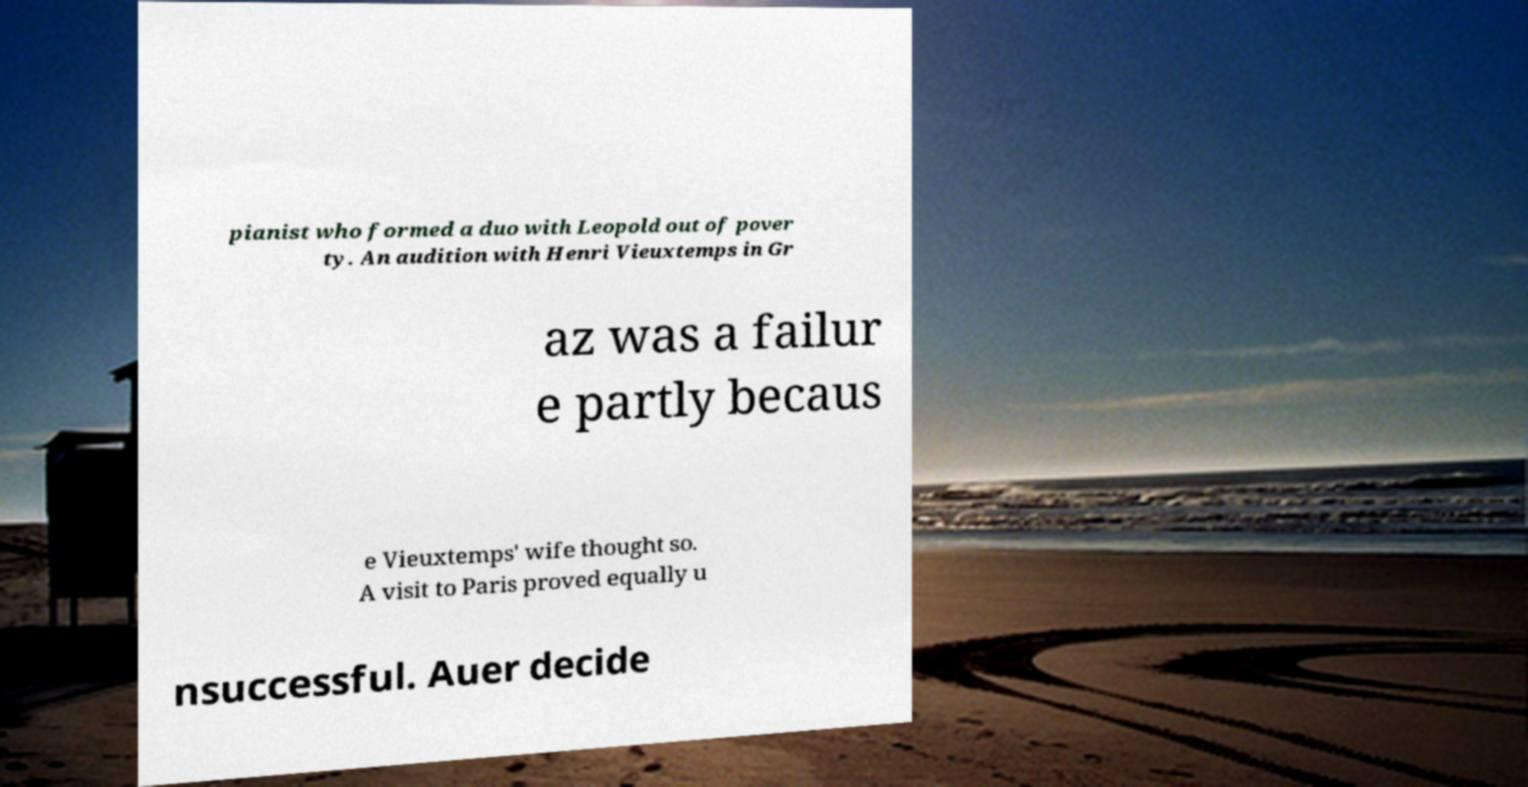Can you read and provide the text displayed in the image?This photo seems to have some interesting text. Can you extract and type it out for me? pianist who formed a duo with Leopold out of pover ty. An audition with Henri Vieuxtemps in Gr az was a failur e partly becaus e Vieuxtemps' wife thought so. A visit to Paris proved equally u nsuccessful. Auer decide 